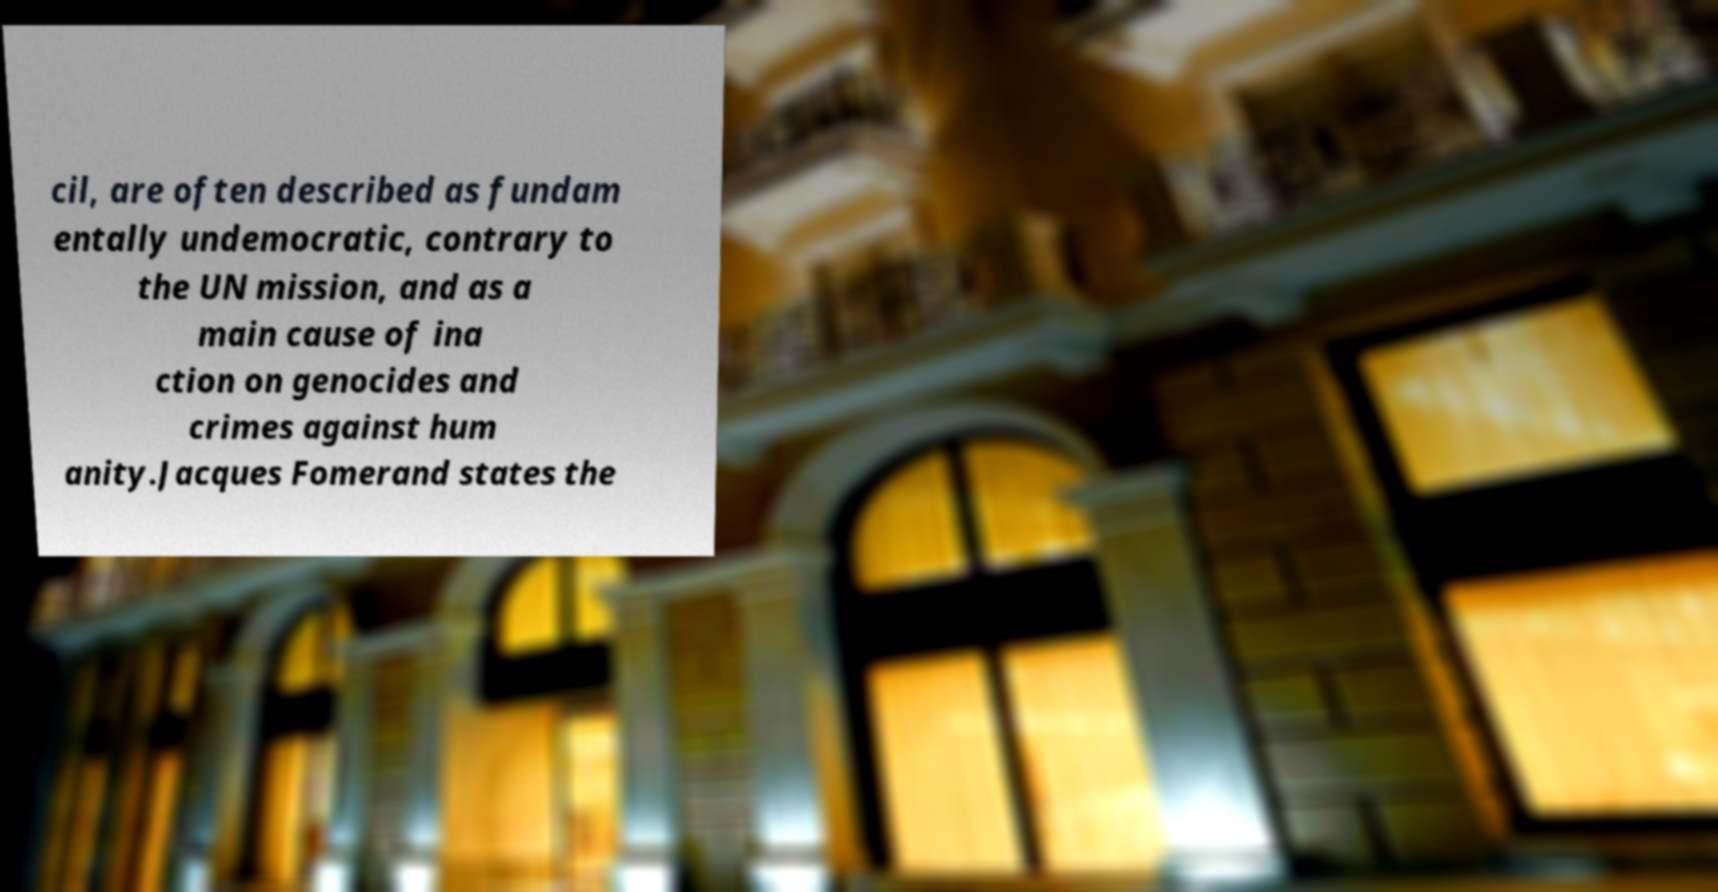I need the written content from this picture converted into text. Can you do that? cil, are often described as fundam entally undemocratic, contrary to the UN mission, and as a main cause of ina ction on genocides and crimes against hum anity.Jacques Fomerand states the 